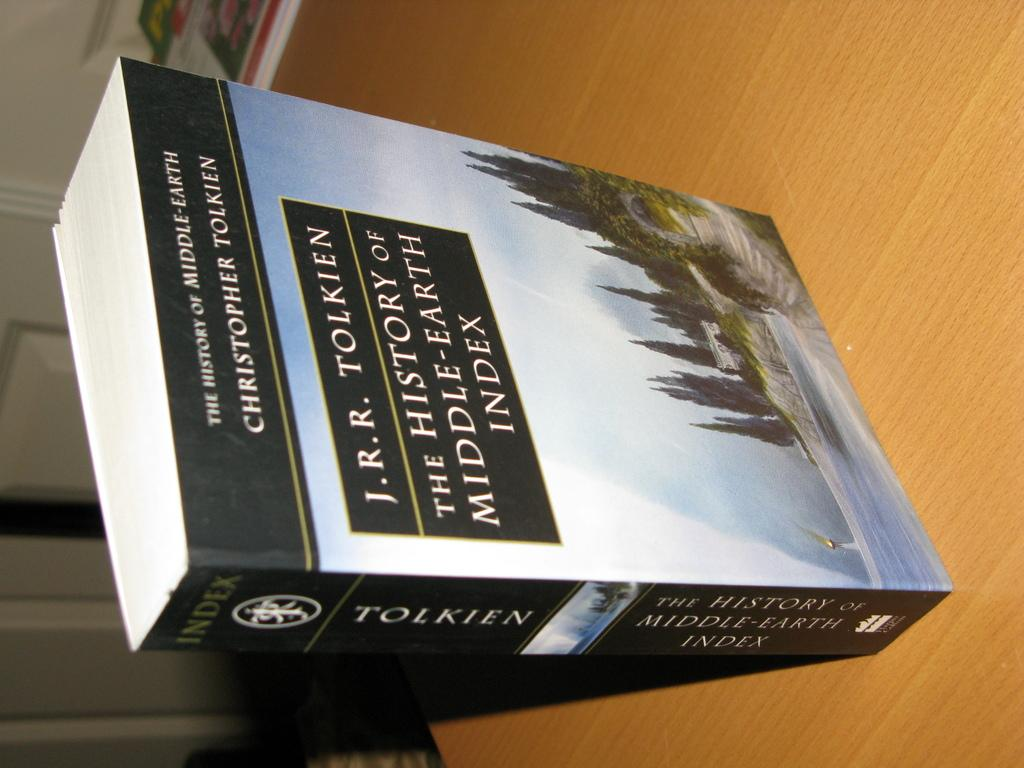<image>
Present a compact description of the photo's key features. A book by J.R.R. Tolkien is on a shelf. 